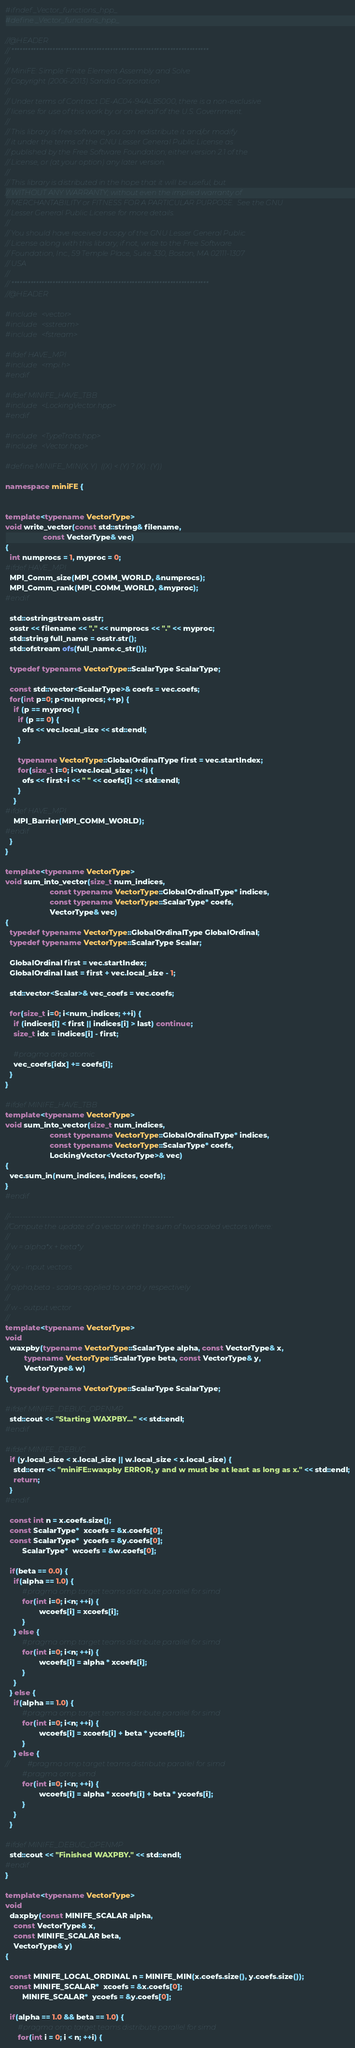<code> <loc_0><loc_0><loc_500><loc_500><_C++_>#ifndef _Vector_functions_hpp_
#define _Vector_functions_hpp_

//@HEADER
// ************************************************************************
//
// MiniFE: Simple Finite Element Assembly and Solve
// Copyright (2006-2013) Sandia Corporation
//
// Under terms of Contract DE-AC04-94AL85000, there is a non-exclusive
// license for use of this work by or on behalf of the U.S. Government.
//
// This library is free software; you can redistribute it and/or modify
// it under the terms of the GNU Lesser General Public License as
// published by the Free Software Foundation; either version 2.1 of the
// License, or (at your option) any later version.
//
// This library is distributed in the hope that it will be useful, but
// WITHOUT ANY WARRANTY; without even the implied warranty of
// MERCHANTABILITY or FITNESS FOR A PARTICULAR PURPOSE.  See the GNU
// Lesser General Public License for more details.
//
// You should have received a copy of the GNU Lesser General Public
// License along with this library; if not, write to the Free Software
// Foundation, Inc., 59 Temple Place, Suite 330, Boston, MA 02111-1307
// USA
//
// ************************************************************************
//@HEADER

#include <vector>
#include <sstream>
#include <fstream>

#ifdef HAVE_MPI
#include <mpi.h>
#endif

#ifdef MINIFE_HAVE_TBB
#include <LockingVector.hpp>
#endif

#include <TypeTraits.hpp>
#include <Vector.hpp>

#define MINIFE_MIN(X, Y)  ((X) < (Y) ? (X) : (Y))

namespace miniFE {


template<typename VectorType>
void write_vector(const std::string& filename,
                  const VectorType& vec)
{
  int numprocs = 1, myproc = 0;
#ifdef HAVE_MPI
  MPI_Comm_size(MPI_COMM_WORLD, &numprocs);
  MPI_Comm_rank(MPI_COMM_WORLD, &myproc);
#endif

  std::ostringstream osstr;
  osstr << filename << "." << numprocs << "." << myproc;
  std::string full_name = osstr.str();
  std::ofstream ofs(full_name.c_str());

  typedef typename VectorType::ScalarType ScalarType;

  const std::vector<ScalarType>& coefs = vec.coefs;
  for(int p=0; p<numprocs; ++p) {
    if (p == myproc) {
      if (p == 0) {
        ofs << vec.local_size << std::endl;
      }
  
      typename VectorType::GlobalOrdinalType first = vec.startIndex;
      for(size_t i=0; i<vec.local_size; ++i) {
        ofs << first+i << " " << coefs[i] << std::endl;
      }
    }
#ifdef HAVE_MPI
    MPI_Barrier(MPI_COMM_WORLD);
#endif
  }
}

template<typename VectorType>
void sum_into_vector(size_t num_indices,
                     const typename VectorType::GlobalOrdinalType* indices,
                     const typename VectorType::ScalarType* coefs,
                     VectorType& vec)
{
  typedef typename VectorType::GlobalOrdinalType GlobalOrdinal;
  typedef typename VectorType::ScalarType Scalar;

  GlobalOrdinal first = vec.startIndex;
  GlobalOrdinal last = first + vec.local_size - 1;

  std::vector<Scalar>& vec_coefs = vec.coefs;

  for(size_t i=0; i<num_indices; ++i) {
    if (indices[i] < first || indices[i] > last) continue;
    size_t idx = indices[i] - first;

    #pragma omp atomic
    vec_coefs[idx] += coefs[i];
  }
}

#ifdef MINIFE_HAVE_TBB
template<typename VectorType>
void sum_into_vector(size_t num_indices,
                     const typename VectorType::GlobalOrdinalType* indices,
                     const typename VectorType::ScalarType* coefs,
                     LockingVector<VectorType>& vec)
{
  vec.sum_in(num_indices, indices, coefs);
}
#endif

//------------------------------------------------------------
//Compute the update of a vector with the sum of two scaled vectors where:
//
// w = alpha*x + beta*y
//
// x,y - input vectors
//
// alpha,beta - scalars applied to x and y respectively
//
// w - output vector
//
template<typename VectorType>
void
  waxpby(typename VectorType::ScalarType alpha, const VectorType& x,
         typename VectorType::ScalarType beta, const VectorType& y,
         VectorType& w)
{
  typedef typename VectorType::ScalarType ScalarType;

#ifdef MINIFE_DEBUG_OPENMP
  std::cout << "Starting WAXPBY..." << std::endl;
#endif

#ifdef MINIFE_DEBUG
  if (y.local_size < x.local_size || w.local_size < x.local_size) {
    std::cerr << "miniFE::waxpby ERROR, y and w must be at least as long as x." << std::endl;
    return;
  }
#endif

  const int n = x.coefs.size();
  const ScalarType*  xcoefs = &x.coefs[0];
  const ScalarType*  ycoefs = &y.coefs[0];
        ScalarType*  wcoefs = &w.coefs[0];

  if(beta == 0.0) {
	if(alpha == 1.0) {
  		#pragma omp target teams distribute parallel for simd
  		for(int i=0; i<n; ++i) {
    			wcoefs[i] = xcoefs[i];
  		}
  	} else {
  		#pragma omp target teams distribute parallel for simd
  		for(int i=0; i<n; ++i) {
    			wcoefs[i] = alpha * xcoefs[i];
  		}
  	}
  } else {
	if(alpha == 1.0) {
  		#pragma omp target teams distribute parallel for simd
  		for(int i=0; i<n; ++i) {
    			wcoefs[i] = xcoefs[i] + beta * ycoefs[i];
  		}
  	} else {
//  		#pragma omp target teams distribute parallel for simd
		#pragma omp simd
  		for(int i=0; i<n; ++i) {
    			wcoefs[i] = alpha * xcoefs[i] + beta * ycoefs[i];
  		}
  	}
  }

#ifdef MINIFE_DEBUG_OPENMP
  std::cout << "Finished WAXPBY." << std::endl;
#endif
}

template<typename VectorType>
void
  daxpby(const MINIFE_SCALAR alpha, 
	const VectorType& x,
	const MINIFE_SCALAR beta, 
	VectorType& y)
{

  const MINIFE_LOCAL_ORDINAL n = MINIFE_MIN(x.coefs.size(), y.coefs.size());
  const MINIFE_SCALAR*  xcoefs = &x.coefs[0];
        MINIFE_SCALAR*  ycoefs = &y.coefs[0];

  if(alpha == 1.0 && beta == 1.0) {
  	  #pragma omp target teams distribute parallel for simd
	  for(int i = 0; i < n; ++i) {</code> 